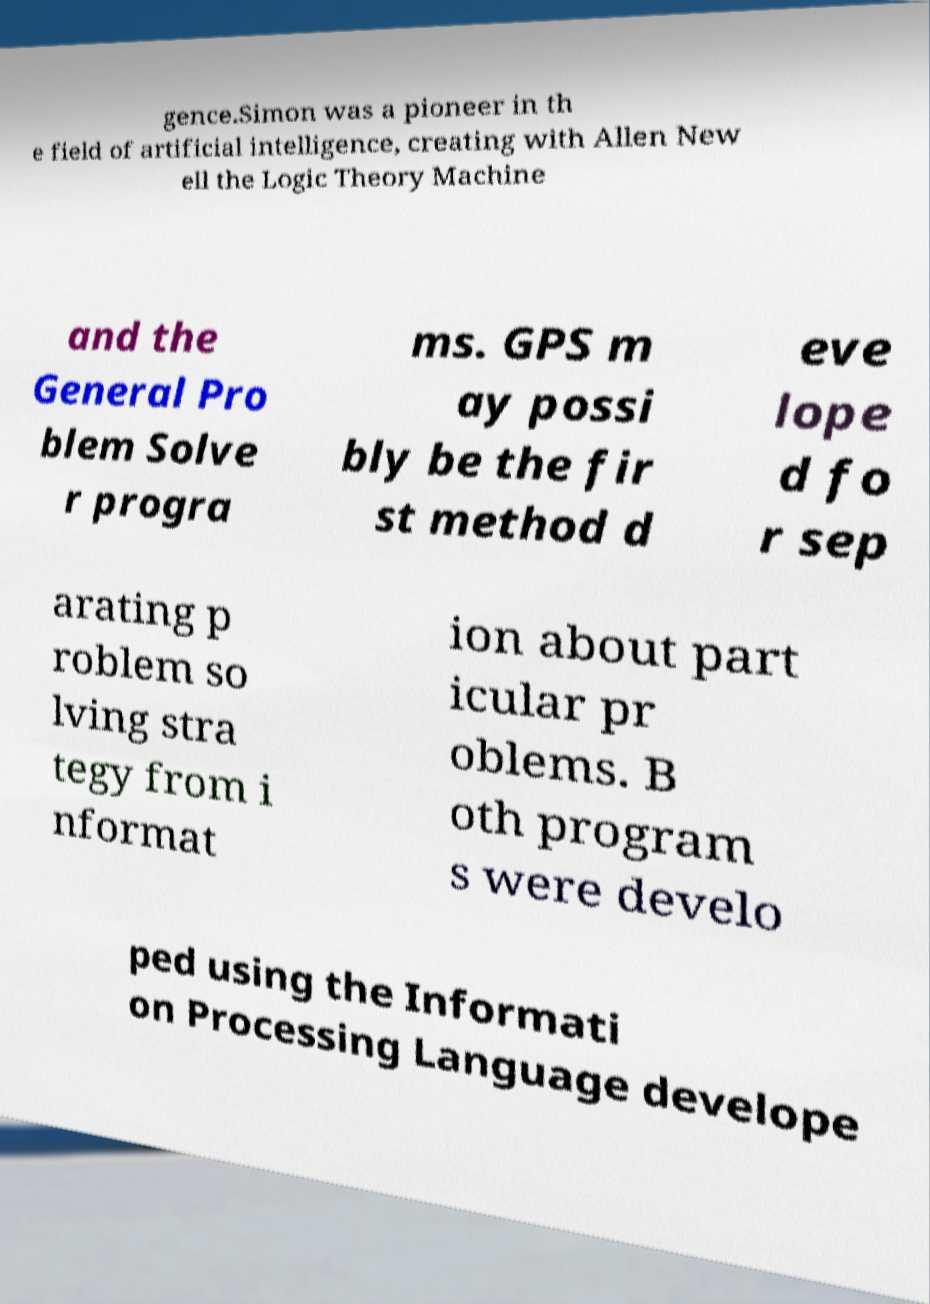Please read and relay the text visible in this image. What does it say? gence.Simon was a pioneer in th e field of artificial intelligence, creating with Allen New ell the Logic Theory Machine and the General Pro blem Solve r progra ms. GPS m ay possi bly be the fir st method d eve lope d fo r sep arating p roblem so lving stra tegy from i nformat ion about part icular pr oblems. B oth program s were develo ped using the Informati on Processing Language develope 